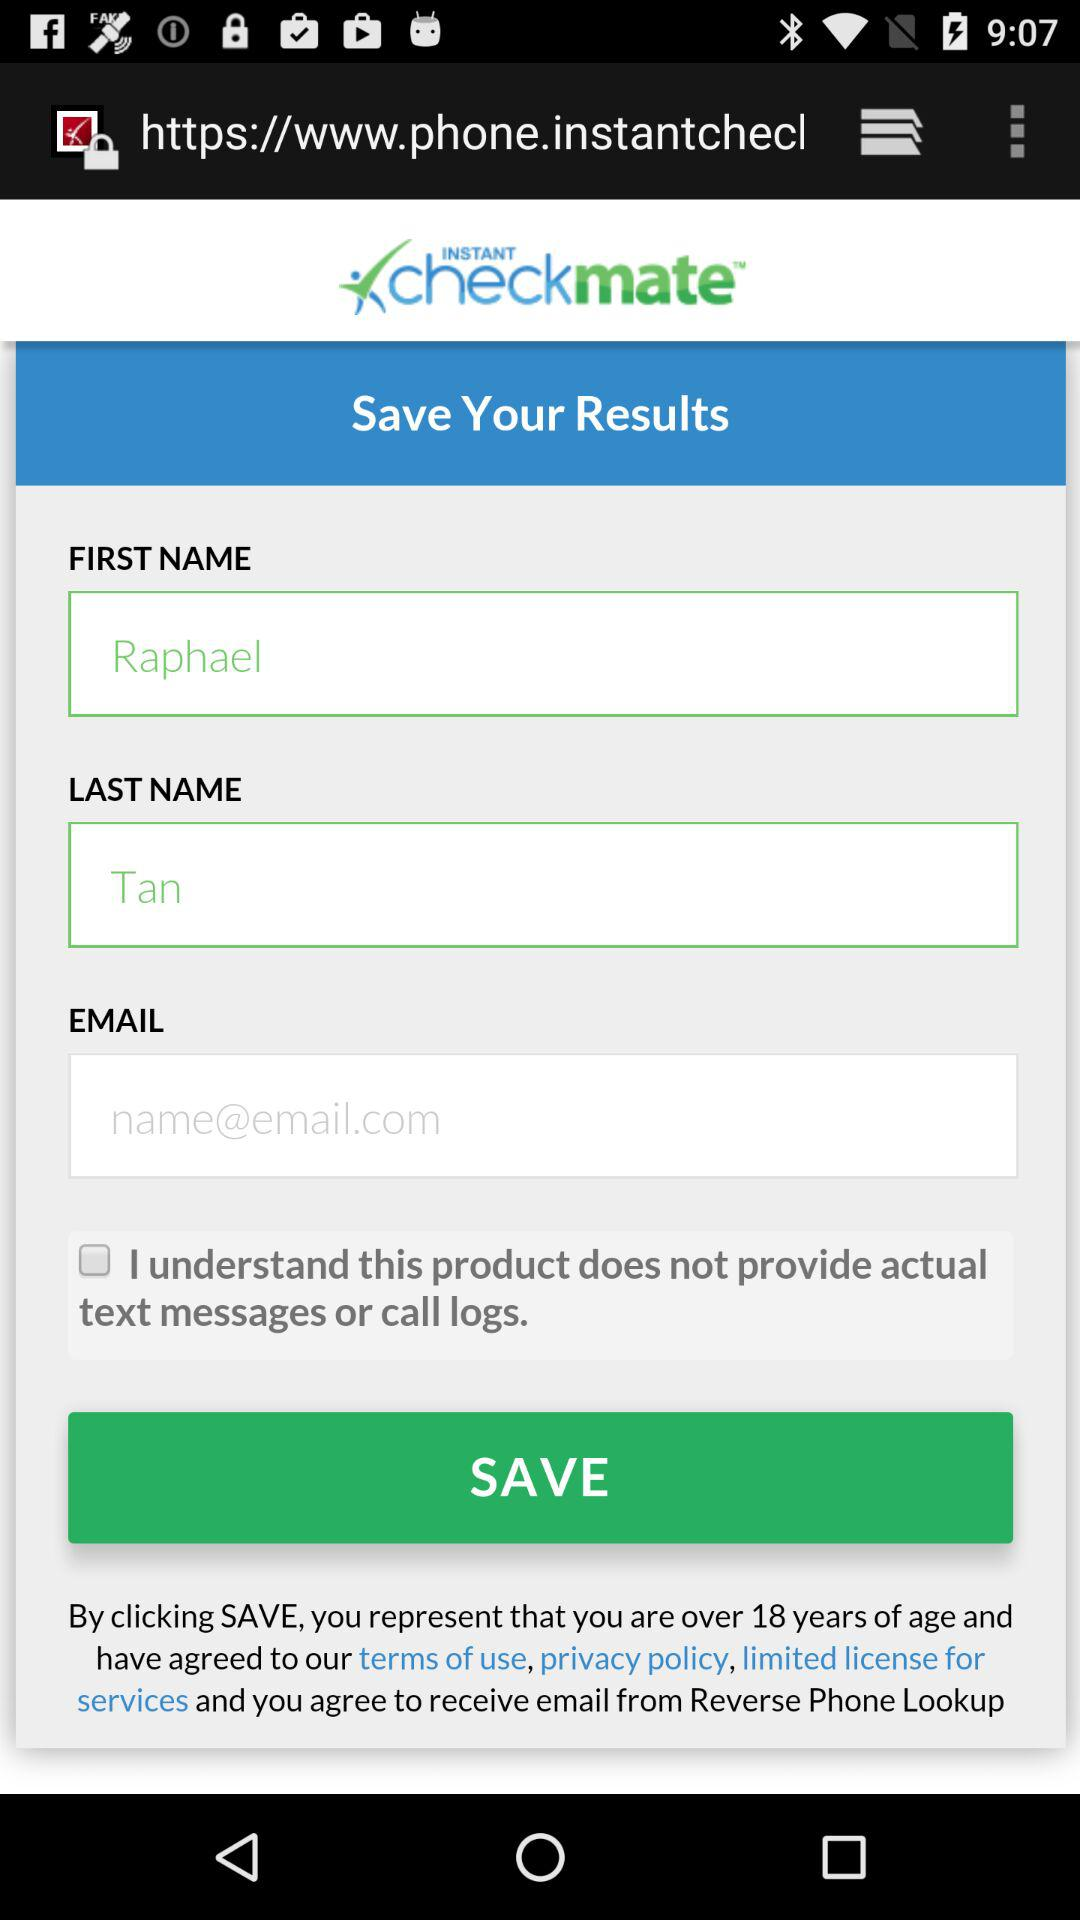What is an Email Address?
When the provided information is insufficient, respond with <no answer>. <no answer> 